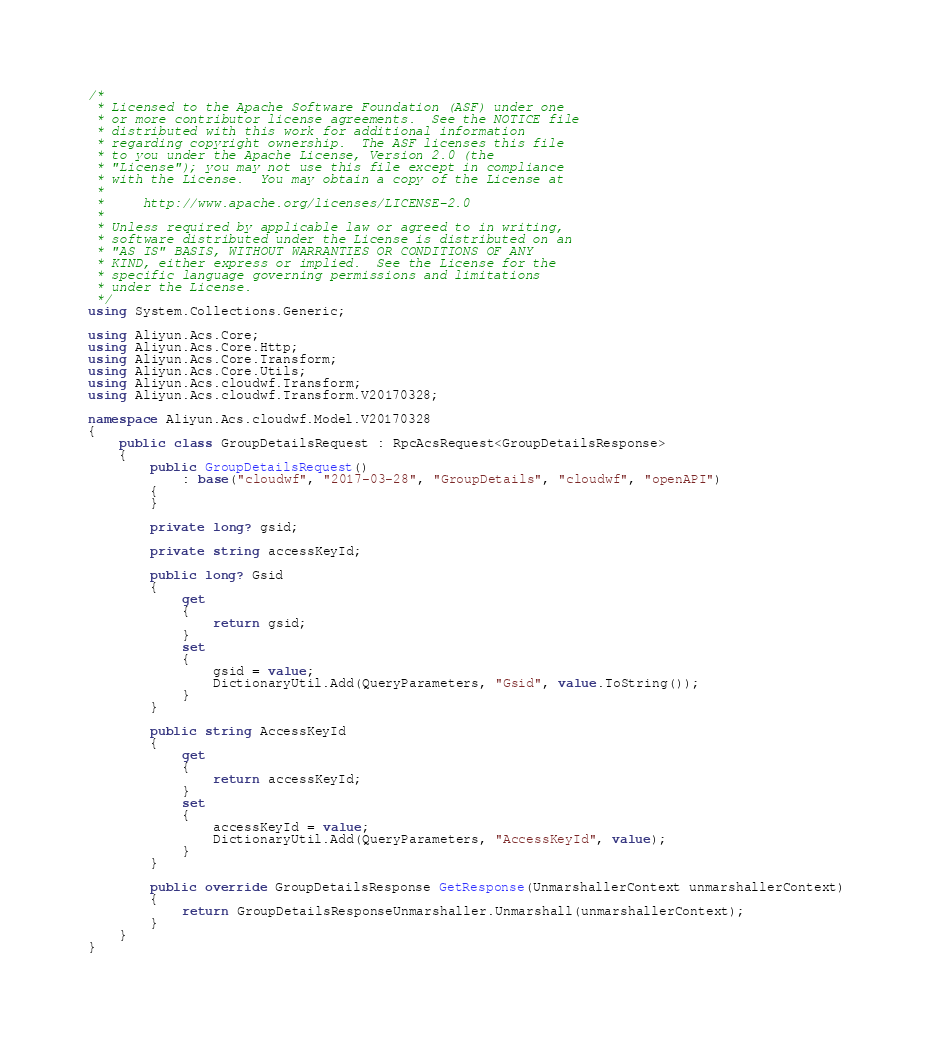Convert code to text. <code><loc_0><loc_0><loc_500><loc_500><_C#_>/*
 * Licensed to the Apache Software Foundation (ASF) under one
 * or more contributor license agreements.  See the NOTICE file
 * distributed with this work for additional information
 * regarding copyright ownership.  The ASF licenses this file
 * to you under the Apache License, Version 2.0 (the
 * "License"); you may not use this file except in compliance
 * with the License.  You may obtain a copy of the License at
 *
 *     http://www.apache.org/licenses/LICENSE-2.0
 *
 * Unless required by applicable law or agreed to in writing,
 * software distributed under the License is distributed on an
 * "AS IS" BASIS, WITHOUT WARRANTIES OR CONDITIONS OF ANY
 * KIND, either express or implied.  See the License for the
 * specific language governing permissions and limitations
 * under the License.
 */
using System.Collections.Generic;

using Aliyun.Acs.Core;
using Aliyun.Acs.Core.Http;
using Aliyun.Acs.Core.Transform;
using Aliyun.Acs.Core.Utils;
using Aliyun.Acs.cloudwf.Transform;
using Aliyun.Acs.cloudwf.Transform.V20170328;

namespace Aliyun.Acs.cloudwf.Model.V20170328
{
    public class GroupDetailsRequest : RpcAcsRequest<GroupDetailsResponse>
    {
        public GroupDetailsRequest()
            : base("cloudwf", "2017-03-28", "GroupDetails", "cloudwf", "openAPI")
        {
        }

		private long? gsid;

		private string accessKeyId;

		public long? Gsid
		{
			get
			{
				return gsid;
			}
			set	
			{
				gsid = value;
				DictionaryUtil.Add(QueryParameters, "Gsid", value.ToString());
			}
		}

		public string AccessKeyId
		{
			get
			{
				return accessKeyId;
			}
			set	
			{
				accessKeyId = value;
				DictionaryUtil.Add(QueryParameters, "AccessKeyId", value);
			}
		}

        public override GroupDetailsResponse GetResponse(UnmarshallerContext unmarshallerContext)
        {
            return GroupDetailsResponseUnmarshaller.Unmarshall(unmarshallerContext);
        }
    }
}
</code> 